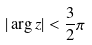Convert formula to latex. <formula><loc_0><loc_0><loc_500><loc_500>| \arg z | < \frac { 3 } { 2 } \pi</formula> 